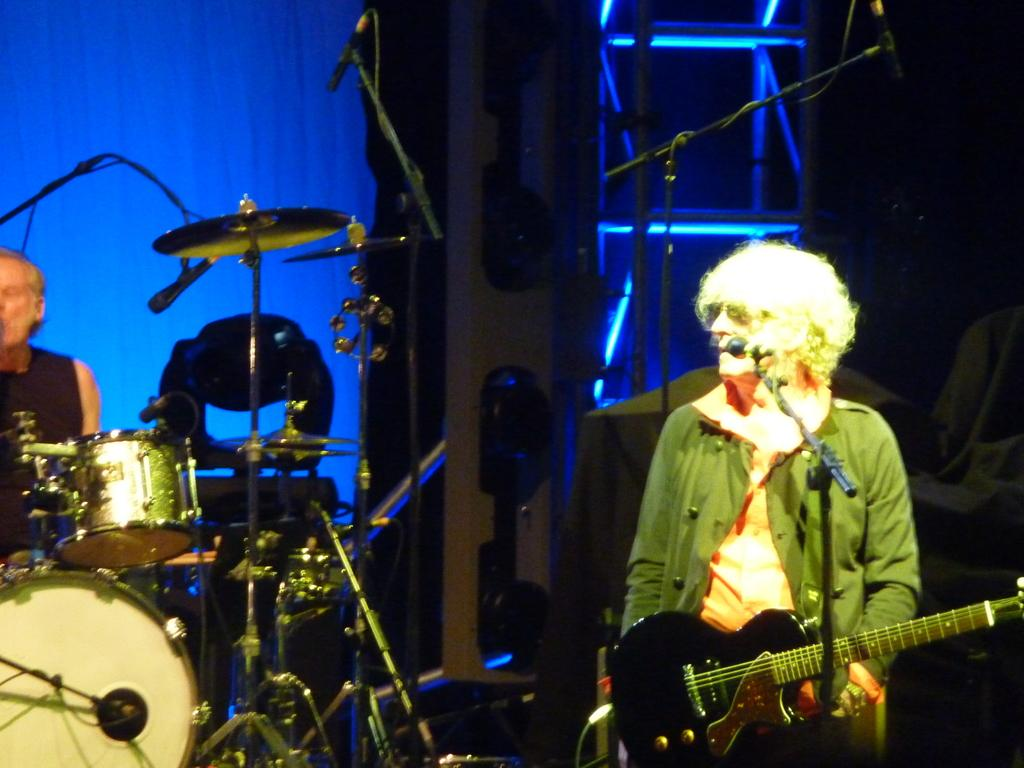Who is the main subject in the image? The main subject in the image is a woman. What is the woman doing in the image? The woman is standing near a microphone and holding a guitar. Are there any other people in the image? Yes, there is a person sitting at a drum set in the image. What is the person doing with the microphone? The person is holding a microphone. How many sheep can be seen in the image? There are no sheep present in the image. What type of table is being used by the woman in the image? There is no table visible in the image; the woman is standing near a microphone and holding a guitar. 